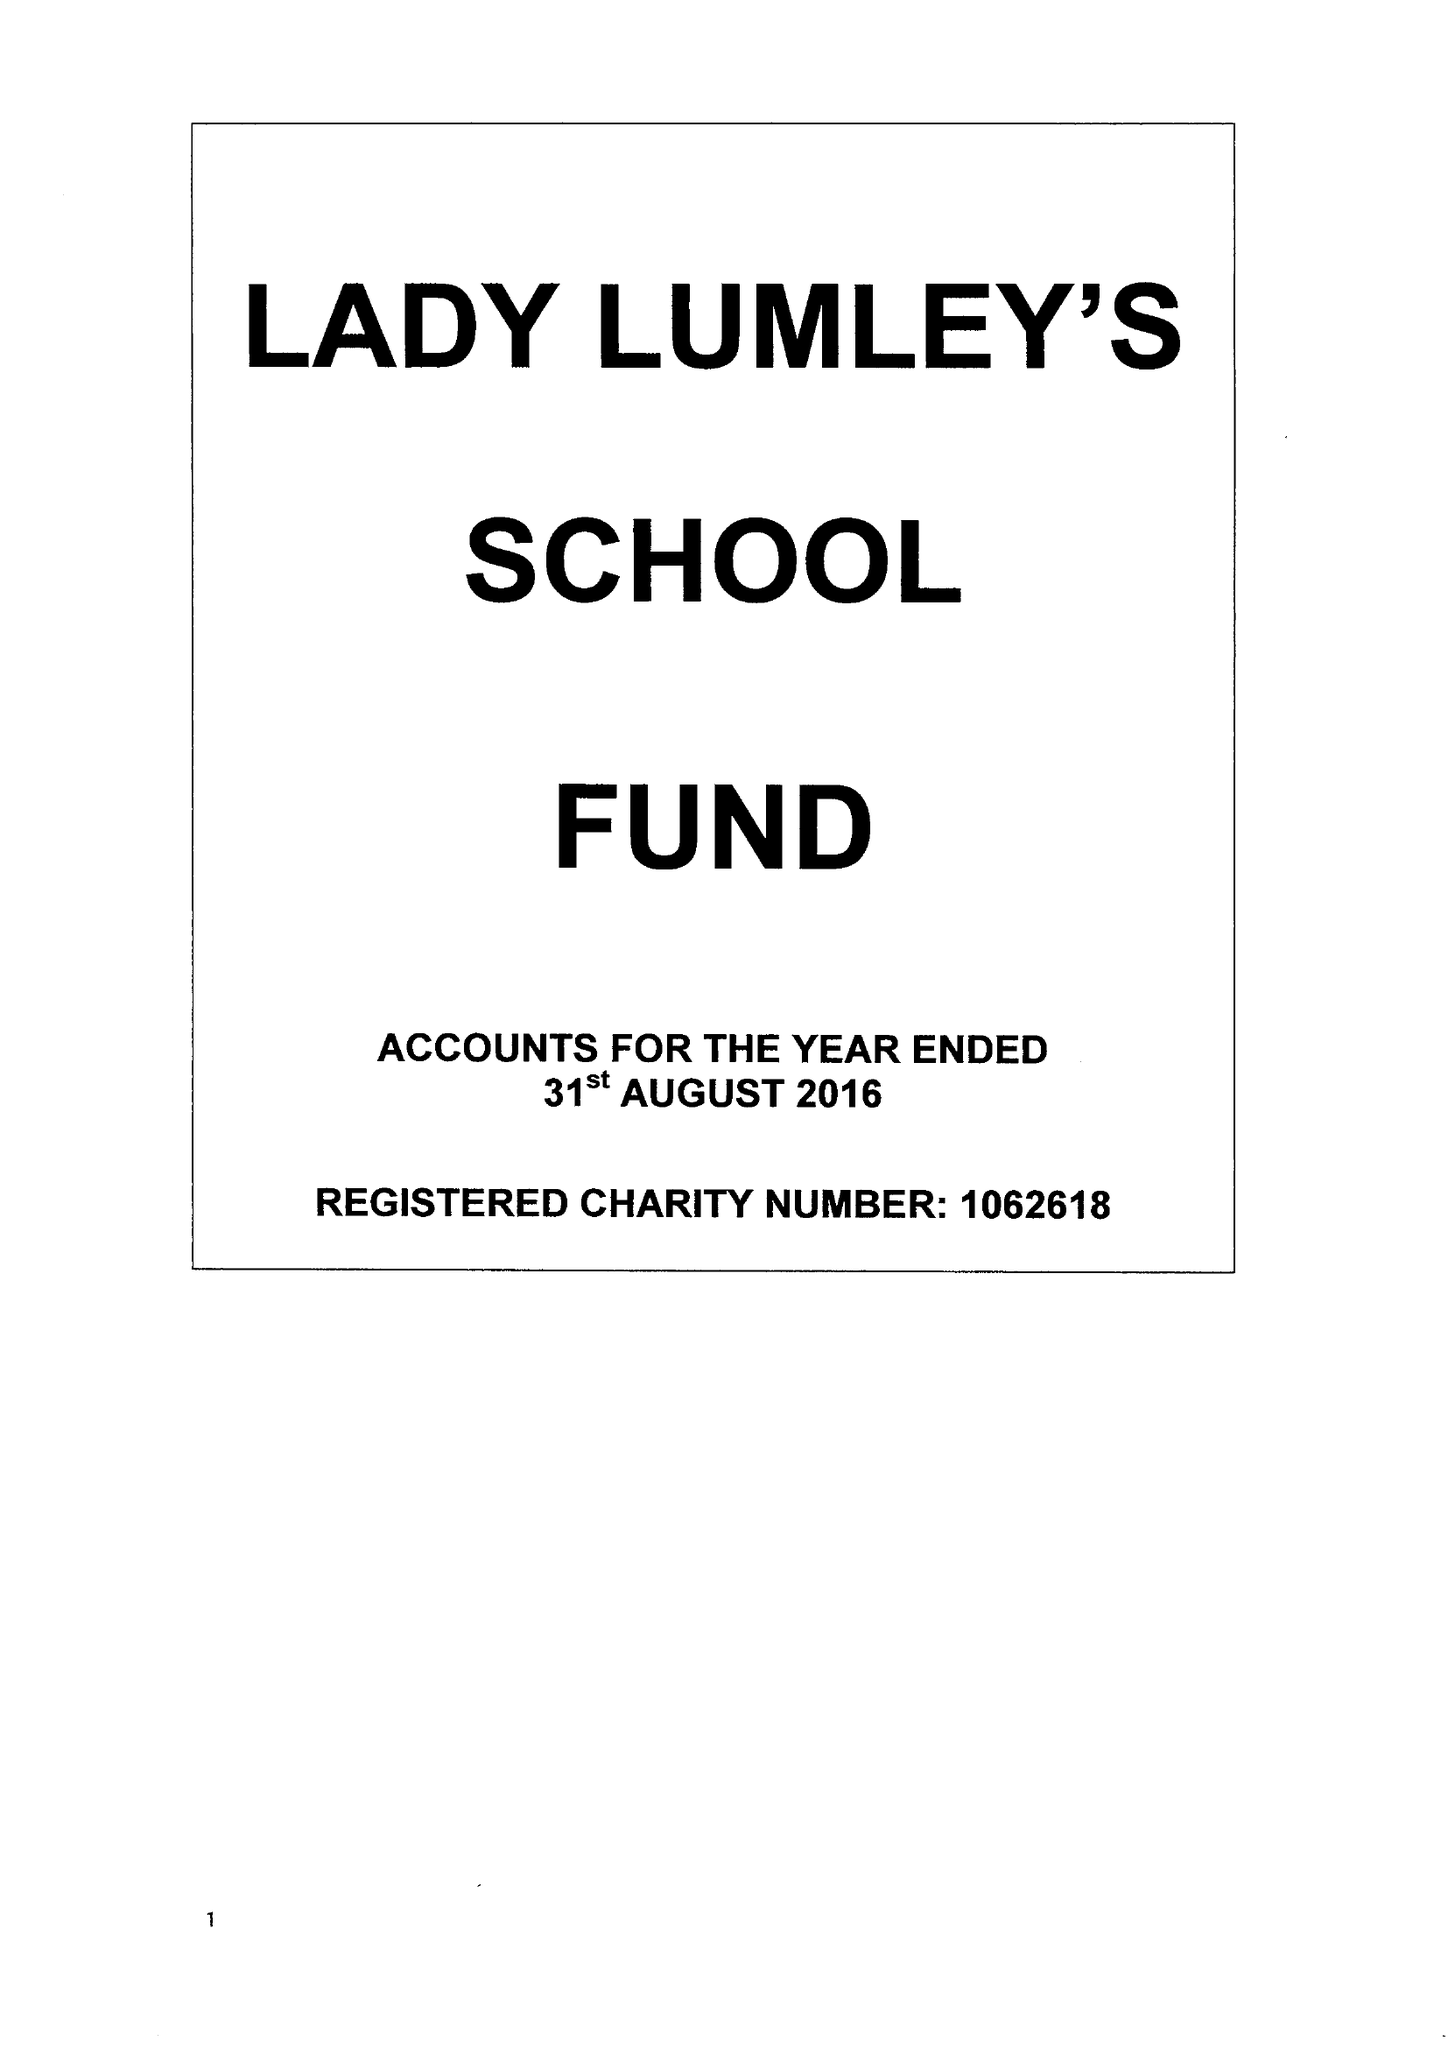What is the value for the address__post_town?
Answer the question using a single word or phrase. PICKERING 